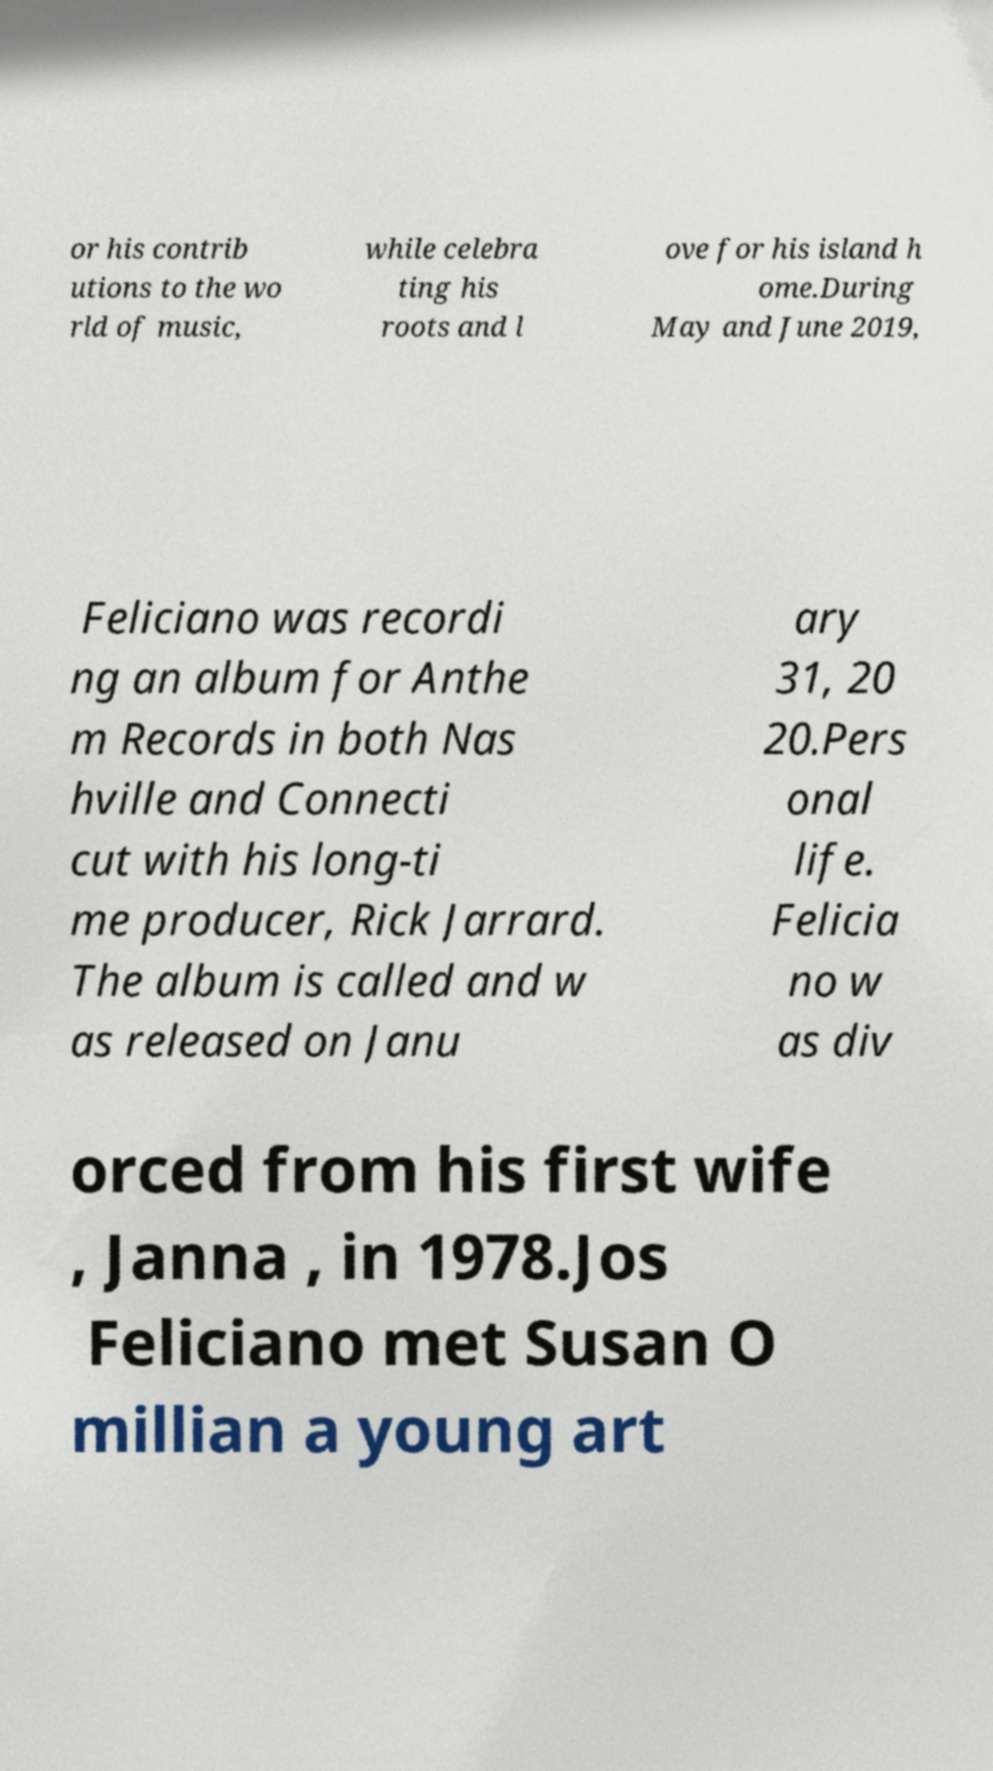What messages or text are displayed in this image? I need them in a readable, typed format. or his contrib utions to the wo rld of music, while celebra ting his roots and l ove for his island h ome.During May and June 2019, Feliciano was recordi ng an album for Anthe m Records in both Nas hville and Connecti cut with his long-ti me producer, Rick Jarrard. The album is called and w as released on Janu ary 31, 20 20.Pers onal life. Felicia no w as div orced from his first wife , Janna , in 1978.Jos Feliciano met Susan O millian a young art 